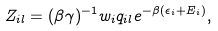<formula> <loc_0><loc_0><loc_500><loc_500>Z _ { i l } = ( \beta \gamma ) ^ { - 1 } w _ { i } q _ { i l } e ^ { - \beta ( \epsilon _ { i } + E _ { i } ) } ,</formula> 